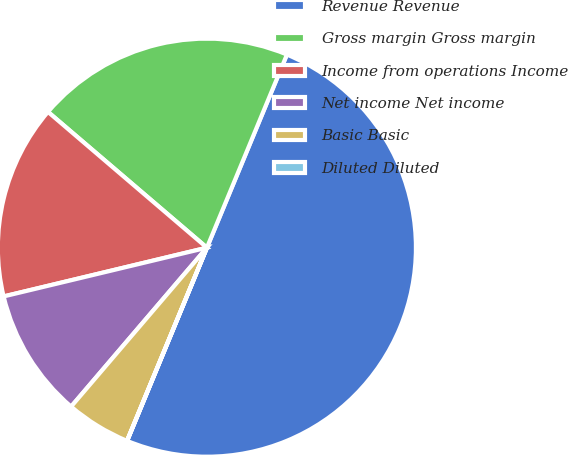Convert chart. <chart><loc_0><loc_0><loc_500><loc_500><pie_chart><fcel>Revenue Revenue<fcel>Gross margin Gross margin<fcel>Income from operations Income<fcel>Net income Net income<fcel>Basic Basic<fcel>Diluted Diluted<nl><fcel>49.98%<fcel>20.0%<fcel>15.0%<fcel>10.0%<fcel>5.01%<fcel>0.01%<nl></chart> 